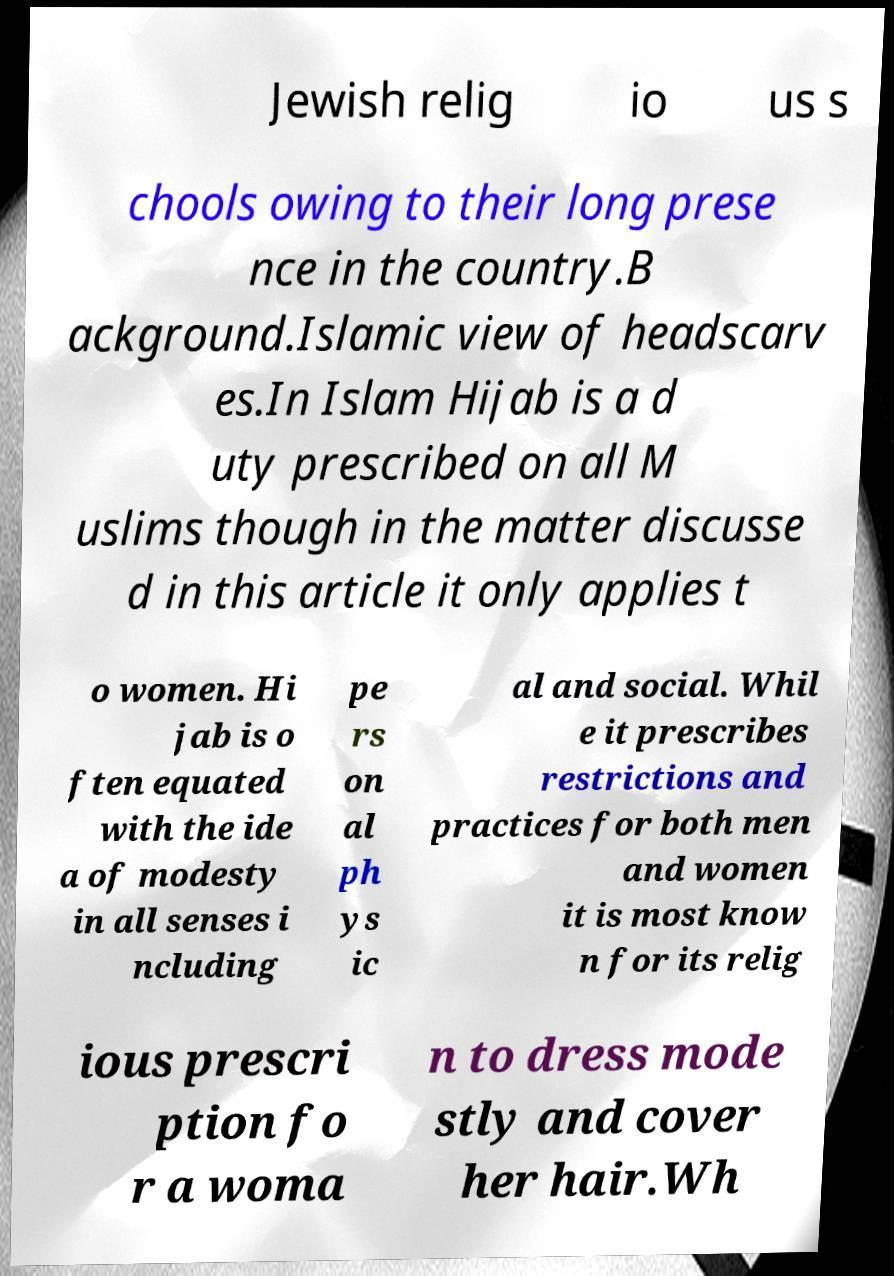Could you extract and type out the text from this image? Jewish relig io us s chools owing to their long prese nce in the country.B ackground.Islamic view of headscarv es.In Islam Hijab is a d uty prescribed on all M uslims though in the matter discusse d in this article it only applies t o women. Hi jab is o ften equated with the ide a of modesty in all senses i ncluding pe rs on al ph ys ic al and social. Whil e it prescribes restrictions and practices for both men and women it is most know n for its relig ious prescri ption fo r a woma n to dress mode stly and cover her hair.Wh 